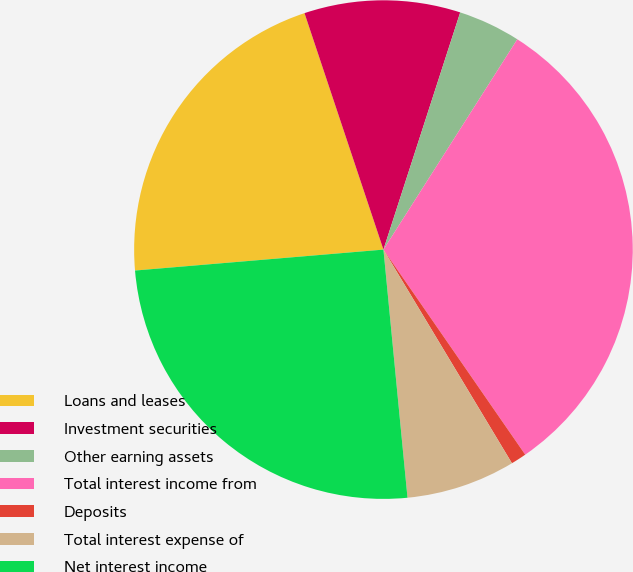<chart> <loc_0><loc_0><loc_500><loc_500><pie_chart><fcel>Loans and leases<fcel>Investment securities<fcel>Other earning assets<fcel>Total interest income from<fcel>Deposits<fcel>Total interest expense of<fcel>Net interest income<nl><fcel>21.21%<fcel>10.11%<fcel>4.04%<fcel>31.35%<fcel>1.01%<fcel>7.08%<fcel>25.2%<nl></chart> 